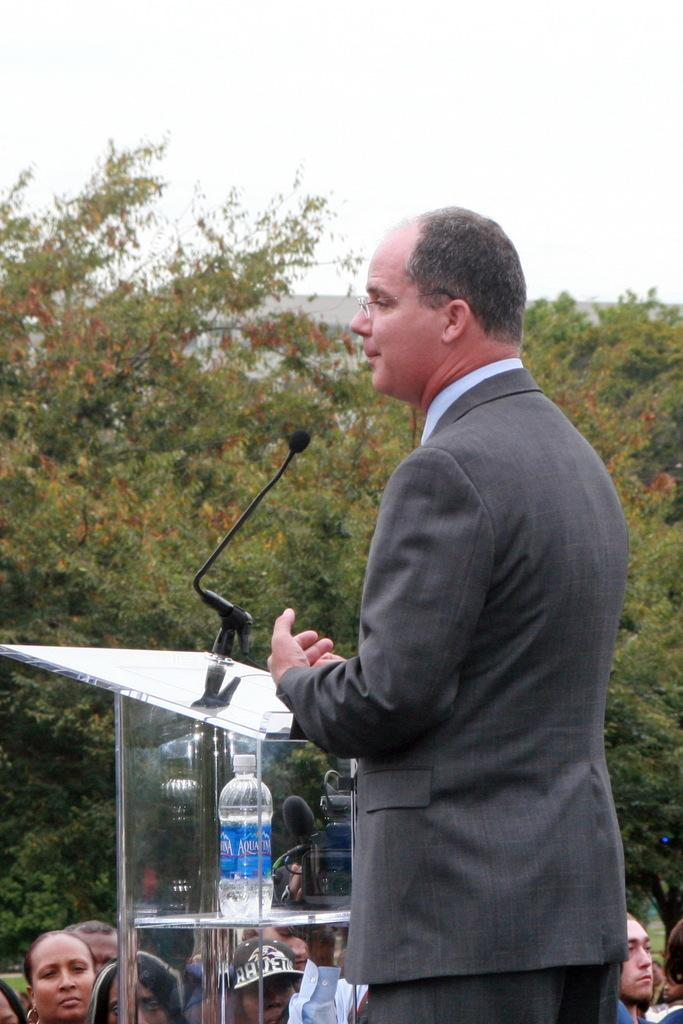Who or what is in the image? There is a person in the image. What is in front of the person? There is a podium in front of the person. What is on the podium? A microphone and a bottle are present on the podium. Are there any other people visible in the image? Yes, there are people visible in the image. What can be seen in the background of the image? Trees, a building, and the sky are visible in the background of the image. How many fingers does the chair have in the image? There is no chair present in the image, so it is not possible to determine the number of fingers it might have. 